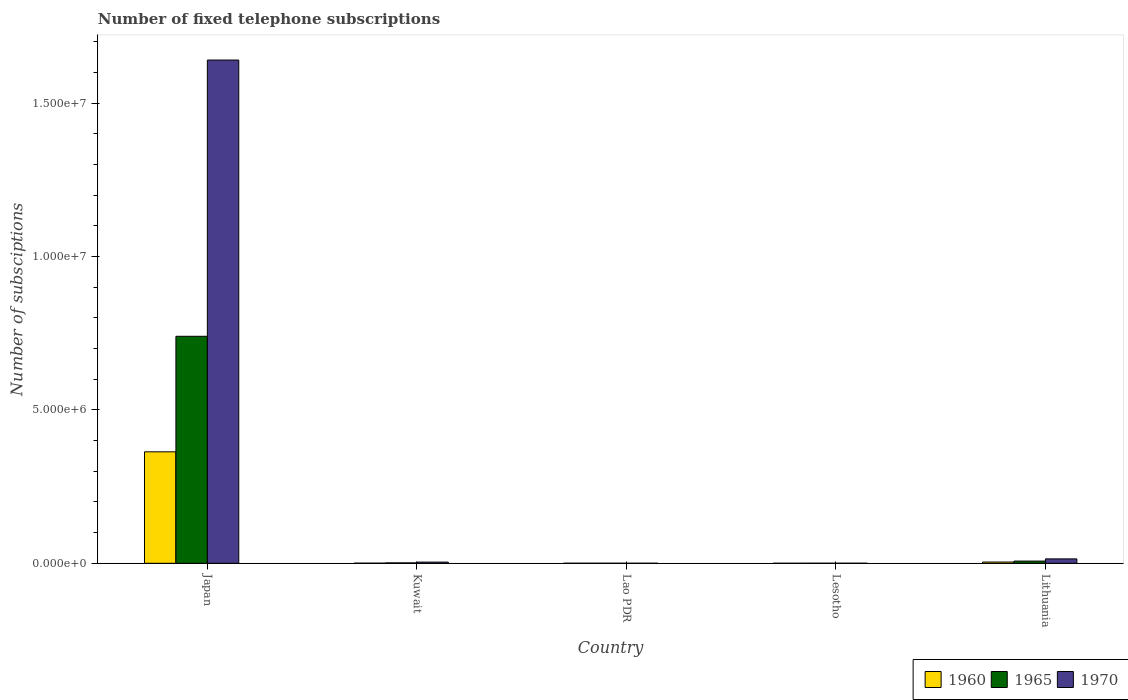How many different coloured bars are there?
Provide a succinct answer. 3. How many groups of bars are there?
Your response must be concise. 5. Are the number of bars per tick equal to the number of legend labels?
Offer a terse response. Yes. Are the number of bars on each tick of the X-axis equal?
Provide a succinct answer. Yes. How many bars are there on the 5th tick from the left?
Ensure brevity in your answer.  3. What is the label of the 2nd group of bars from the left?
Provide a succinct answer. Kuwait. In how many cases, is the number of bars for a given country not equal to the number of legend labels?
Offer a terse response. 0. What is the number of fixed telephone subscriptions in 1960 in Lithuania?
Offer a terse response. 4.04e+04. Across all countries, what is the maximum number of fixed telephone subscriptions in 1965?
Give a very brief answer. 7.40e+06. Across all countries, what is the minimum number of fixed telephone subscriptions in 1970?
Ensure brevity in your answer.  1100. In which country was the number of fixed telephone subscriptions in 1965 maximum?
Provide a short and direct response. Japan. In which country was the number of fixed telephone subscriptions in 1965 minimum?
Your answer should be compact. Lao PDR. What is the total number of fixed telephone subscriptions in 1960 in the graph?
Your answer should be compact. 3.68e+06. What is the difference between the number of fixed telephone subscriptions in 1960 in Lao PDR and that in Lesotho?
Offer a very short reply. 336. What is the difference between the number of fixed telephone subscriptions in 1970 in Lesotho and the number of fixed telephone subscriptions in 1960 in Kuwait?
Keep it short and to the point. -2016. What is the average number of fixed telephone subscriptions in 1960 per country?
Provide a succinct answer. 7.36e+05. What is the difference between the number of fixed telephone subscriptions of/in 1965 and number of fixed telephone subscriptions of/in 1970 in Kuwait?
Keep it short and to the point. -2.50e+04. In how many countries, is the number of fixed telephone subscriptions in 1965 greater than 1000000?
Provide a succinct answer. 1. What is the ratio of the number of fixed telephone subscriptions in 1965 in Kuwait to that in Lesotho?
Your answer should be compact. 10.83. Is the number of fixed telephone subscriptions in 1970 in Lesotho less than that in Lithuania?
Your answer should be compact. Yes. Is the difference between the number of fixed telephone subscriptions in 1965 in Lesotho and Lithuania greater than the difference between the number of fixed telephone subscriptions in 1970 in Lesotho and Lithuania?
Your response must be concise. Yes. What is the difference between the highest and the second highest number of fixed telephone subscriptions in 1970?
Keep it short and to the point. 1.63e+07. What is the difference between the highest and the lowest number of fixed telephone subscriptions in 1970?
Your response must be concise. 1.64e+07. Is the sum of the number of fixed telephone subscriptions in 1960 in Japan and Kuwait greater than the maximum number of fixed telephone subscriptions in 1970 across all countries?
Your answer should be very brief. No. What does the 3rd bar from the left in Kuwait represents?
Your answer should be compact. 1970. What does the 3rd bar from the right in Lao PDR represents?
Ensure brevity in your answer.  1960. How many countries are there in the graph?
Ensure brevity in your answer.  5. What is the title of the graph?
Give a very brief answer. Number of fixed telephone subscriptions. Does "1992" appear as one of the legend labels in the graph?
Your response must be concise. No. What is the label or title of the Y-axis?
Your answer should be very brief. Number of subsciptions. What is the Number of subsciptions in 1960 in Japan?
Your answer should be very brief. 3.63e+06. What is the Number of subsciptions in 1965 in Japan?
Make the answer very short. 7.40e+06. What is the Number of subsciptions of 1970 in Japan?
Provide a succinct answer. 1.64e+07. What is the Number of subsciptions of 1960 in Kuwait?
Your answer should be compact. 3316. What is the Number of subsciptions of 1965 in Kuwait?
Provide a succinct answer. 1.30e+04. What is the Number of subsciptions of 1970 in Kuwait?
Provide a short and direct response. 3.80e+04. What is the Number of subsciptions of 1960 in Lao PDR?
Offer a very short reply. 736. What is the Number of subsciptions in 1965 in Lao PDR?
Provide a short and direct response. 1000. What is the Number of subsciptions of 1970 in Lao PDR?
Keep it short and to the point. 1100. What is the Number of subsciptions of 1960 in Lesotho?
Provide a short and direct response. 400. What is the Number of subsciptions of 1965 in Lesotho?
Ensure brevity in your answer.  1200. What is the Number of subsciptions of 1970 in Lesotho?
Your answer should be very brief. 1300. What is the Number of subsciptions in 1960 in Lithuania?
Offer a terse response. 4.04e+04. What is the Number of subsciptions of 1965 in Lithuania?
Give a very brief answer. 7.18e+04. What is the Number of subsciptions in 1970 in Lithuania?
Keep it short and to the point. 1.43e+05. Across all countries, what is the maximum Number of subsciptions in 1960?
Provide a short and direct response. 3.63e+06. Across all countries, what is the maximum Number of subsciptions of 1965?
Offer a very short reply. 7.40e+06. Across all countries, what is the maximum Number of subsciptions in 1970?
Your answer should be very brief. 1.64e+07. Across all countries, what is the minimum Number of subsciptions of 1960?
Your response must be concise. 400. Across all countries, what is the minimum Number of subsciptions of 1965?
Provide a succinct answer. 1000. Across all countries, what is the minimum Number of subsciptions in 1970?
Your answer should be very brief. 1100. What is the total Number of subsciptions in 1960 in the graph?
Ensure brevity in your answer.  3.68e+06. What is the total Number of subsciptions in 1965 in the graph?
Your answer should be very brief. 7.49e+06. What is the total Number of subsciptions of 1970 in the graph?
Your response must be concise. 1.66e+07. What is the difference between the Number of subsciptions of 1960 in Japan and that in Kuwait?
Offer a very short reply. 3.63e+06. What is the difference between the Number of subsciptions of 1965 in Japan and that in Kuwait?
Give a very brief answer. 7.39e+06. What is the difference between the Number of subsciptions of 1970 in Japan and that in Kuwait?
Offer a terse response. 1.64e+07. What is the difference between the Number of subsciptions of 1960 in Japan and that in Lao PDR?
Offer a very short reply. 3.63e+06. What is the difference between the Number of subsciptions in 1965 in Japan and that in Lao PDR?
Make the answer very short. 7.40e+06. What is the difference between the Number of subsciptions of 1970 in Japan and that in Lao PDR?
Give a very brief answer. 1.64e+07. What is the difference between the Number of subsciptions in 1960 in Japan and that in Lesotho?
Ensure brevity in your answer.  3.63e+06. What is the difference between the Number of subsciptions of 1965 in Japan and that in Lesotho?
Provide a succinct answer. 7.40e+06. What is the difference between the Number of subsciptions of 1970 in Japan and that in Lesotho?
Your response must be concise. 1.64e+07. What is the difference between the Number of subsciptions in 1960 in Japan and that in Lithuania?
Ensure brevity in your answer.  3.59e+06. What is the difference between the Number of subsciptions of 1965 in Japan and that in Lithuania?
Your answer should be compact. 7.33e+06. What is the difference between the Number of subsciptions of 1970 in Japan and that in Lithuania?
Ensure brevity in your answer.  1.63e+07. What is the difference between the Number of subsciptions in 1960 in Kuwait and that in Lao PDR?
Provide a short and direct response. 2580. What is the difference between the Number of subsciptions in 1965 in Kuwait and that in Lao PDR?
Make the answer very short. 1.20e+04. What is the difference between the Number of subsciptions in 1970 in Kuwait and that in Lao PDR?
Offer a terse response. 3.69e+04. What is the difference between the Number of subsciptions of 1960 in Kuwait and that in Lesotho?
Ensure brevity in your answer.  2916. What is the difference between the Number of subsciptions of 1965 in Kuwait and that in Lesotho?
Give a very brief answer. 1.18e+04. What is the difference between the Number of subsciptions of 1970 in Kuwait and that in Lesotho?
Offer a very short reply. 3.67e+04. What is the difference between the Number of subsciptions in 1960 in Kuwait and that in Lithuania?
Ensure brevity in your answer.  -3.71e+04. What is the difference between the Number of subsciptions of 1965 in Kuwait and that in Lithuania?
Make the answer very short. -5.88e+04. What is the difference between the Number of subsciptions of 1970 in Kuwait and that in Lithuania?
Make the answer very short. -1.05e+05. What is the difference between the Number of subsciptions of 1960 in Lao PDR and that in Lesotho?
Provide a short and direct response. 336. What is the difference between the Number of subsciptions in 1965 in Lao PDR and that in Lesotho?
Provide a succinct answer. -200. What is the difference between the Number of subsciptions in 1970 in Lao PDR and that in Lesotho?
Keep it short and to the point. -200. What is the difference between the Number of subsciptions in 1960 in Lao PDR and that in Lithuania?
Offer a terse response. -3.97e+04. What is the difference between the Number of subsciptions in 1965 in Lao PDR and that in Lithuania?
Your answer should be compact. -7.08e+04. What is the difference between the Number of subsciptions in 1970 in Lao PDR and that in Lithuania?
Offer a very short reply. -1.42e+05. What is the difference between the Number of subsciptions of 1960 in Lesotho and that in Lithuania?
Ensure brevity in your answer.  -4.00e+04. What is the difference between the Number of subsciptions of 1965 in Lesotho and that in Lithuania?
Your answer should be very brief. -7.06e+04. What is the difference between the Number of subsciptions of 1970 in Lesotho and that in Lithuania?
Give a very brief answer. -1.42e+05. What is the difference between the Number of subsciptions of 1960 in Japan and the Number of subsciptions of 1965 in Kuwait?
Your answer should be very brief. 3.62e+06. What is the difference between the Number of subsciptions of 1960 in Japan and the Number of subsciptions of 1970 in Kuwait?
Provide a short and direct response. 3.59e+06. What is the difference between the Number of subsciptions of 1965 in Japan and the Number of subsciptions of 1970 in Kuwait?
Keep it short and to the point. 7.36e+06. What is the difference between the Number of subsciptions in 1960 in Japan and the Number of subsciptions in 1965 in Lao PDR?
Your answer should be very brief. 3.63e+06. What is the difference between the Number of subsciptions of 1960 in Japan and the Number of subsciptions of 1970 in Lao PDR?
Give a very brief answer. 3.63e+06. What is the difference between the Number of subsciptions of 1965 in Japan and the Number of subsciptions of 1970 in Lao PDR?
Give a very brief answer. 7.40e+06. What is the difference between the Number of subsciptions of 1960 in Japan and the Number of subsciptions of 1965 in Lesotho?
Ensure brevity in your answer.  3.63e+06. What is the difference between the Number of subsciptions of 1960 in Japan and the Number of subsciptions of 1970 in Lesotho?
Give a very brief answer. 3.63e+06. What is the difference between the Number of subsciptions in 1965 in Japan and the Number of subsciptions in 1970 in Lesotho?
Offer a terse response. 7.40e+06. What is the difference between the Number of subsciptions of 1960 in Japan and the Number of subsciptions of 1965 in Lithuania?
Ensure brevity in your answer.  3.56e+06. What is the difference between the Number of subsciptions in 1960 in Japan and the Number of subsciptions in 1970 in Lithuania?
Your response must be concise. 3.49e+06. What is the difference between the Number of subsciptions in 1965 in Japan and the Number of subsciptions in 1970 in Lithuania?
Your response must be concise. 7.26e+06. What is the difference between the Number of subsciptions in 1960 in Kuwait and the Number of subsciptions in 1965 in Lao PDR?
Give a very brief answer. 2316. What is the difference between the Number of subsciptions of 1960 in Kuwait and the Number of subsciptions of 1970 in Lao PDR?
Keep it short and to the point. 2216. What is the difference between the Number of subsciptions in 1965 in Kuwait and the Number of subsciptions in 1970 in Lao PDR?
Keep it short and to the point. 1.19e+04. What is the difference between the Number of subsciptions of 1960 in Kuwait and the Number of subsciptions of 1965 in Lesotho?
Keep it short and to the point. 2116. What is the difference between the Number of subsciptions of 1960 in Kuwait and the Number of subsciptions of 1970 in Lesotho?
Your answer should be compact. 2016. What is the difference between the Number of subsciptions in 1965 in Kuwait and the Number of subsciptions in 1970 in Lesotho?
Your response must be concise. 1.17e+04. What is the difference between the Number of subsciptions of 1960 in Kuwait and the Number of subsciptions of 1965 in Lithuania?
Give a very brief answer. -6.85e+04. What is the difference between the Number of subsciptions of 1960 in Kuwait and the Number of subsciptions of 1970 in Lithuania?
Offer a terse response. -1.40e+05. What is the difference between the Number of subsciptions of 1965 in Kuwait and the Number of subsciptions of 1970 in Lithuania?
Your response must be concise. -1.30e+05. What is the difference between the Number of subsciptions in 1960 in Lao PDR and the Number of subsciptions in 1965 in Lesotho?
Your response must be concise. -464. What is the difference between the Number of subsciptions in 1960 in Lao PDR and the Number of subsciptions in 1970 in Lesotho?
Keep it short and to the point. -564. What is the difference between the Number of subsciptions of 1965 in Lao PDR and the Number of subsciptions of 1970 in Lesotho?
Give a very brief answer. -300. What is the difference between the Number of subsciptions of 1960 in Lao PDR and the Number of subsciptions of 1965 in Lithuania?
Your response must be concise. -7.11e+04. What is the difference between the Number of subsciptions of 1960 in Lao PDR and the Number of subsciptions of 1970 in Lithuania?
Your answer should be very brief. -1.42e+05. What is the difference between the Number of subsciptions of 1965 in Lao PDR and the Number of subsciptions of 1970 in Lithuania?
Provide a succinct answer. -1.42e+05. What is the difference between the Number of subsciptions in 1960 in Lesotho and the Number of subsciptions in 1965 in Lithuania?
Your answer should be very brief. -7.14e+04. What is the difference between the Number of subsciptions of 1960 in Lesotho and the Number of subsciptions of 1970 in Lithuania?
Your answer should be very brief. -1.43e+05. What is the difference between the Number of subsciptions in 1965 in Lesotho and the Number of subsciptions in 1970 in Lithuania?
Keep it short and to the point. -1.42e+05. What is the average Number of subsciptions in 1960 per country?
Your answer should be very brief. 7.36e+05. What is the average Number of subsciptions in 1965 per country?
Offer a terse response. 1.50e+06. What is the average Number of subsciptions in 1970 per country?
Your answer should be very brief. 3.32e+06. What is the difference between the Number of subsciptions in 1960 and Number of subsciptions in 1965 in Japan?
Your answer should be very brief. -3.77e+06. What is the difference between the Number of subsciptions in 1960 and Number of subsciptions in 1970 in Japan?
Provide a short and direct response. -1.28e+07. What is the difference between the Number of subsciptions in 1965 and Number of subsciptions in 1970 in Japan?
Your answer should be compact. -9.00e+06. What is the difference between the Number of subsciptions in 1960 and Number of subsciptions in 1965 in Kuwait?
Make the answer very short. -9684. What is the difference between the Number of subsciptions in 1960 and Number of subsciptions in 1970 in Kuwait?
Your response must be concise. -3.47e+04. What is the difference between the Number of subsciptions in 1965 and Number of subsciptions in 1970 in Kuwait?
Offer a terse response. -2.50e+04. What is the difference between the Number of subsciptions of 1960 and Number of subsciptions of 1965 in Lao PDR?
Your answer should be very brief. -264. What is the difference between the Number of subsciptions in 1960 and Number of subsciptions in 1970 in Lao PDR?
Provide a succinct answer. -364. What is the difference between the Number of subsciptions in 1965 and Number of subsciptions in 1970 in Lao PDR?
Provide a succinct answer. -100. What is the difference between the Number of subsciptions of 1960 and Number of subsciptions of 1965 in Lesotho?
Provide a succinct answer. -800. What is the difference between the Number of subsciptions in 1960 and Number of subsciptions in 1970 in Lesotho?
Provide a short and direct response. -900. What is the difference between the Number of subsciptions of 1965 and Number of subsciptions of 1970 in Lesotho?
Ensure brevity in your answer.  -100. What is the difference between the Number of subsciptions of 1960 and Number of subsciptions of 1965 in Lithuania?
Your answer should be compact. -3.15e+04. What is the difference between the Number of subsciptions of 1960 and Number of subsciptions of 1970 in Lithuania?
Offer a terse response. -1.03e+05. What is the difference between the Number of subsciptions in 1965 and Number of subsciptions in 1970 in Lithuania?
Ensure brevity in your answer.  -7.14e+04. What is the ratio of the Number of subsciptions of 1960 in Japan to that in Kuwait?
Make the answer very short. 1095.58. What is the ratio of the Number of subsciptions in 1965 in Japan to that in Kuwait?
Provide a short and direct response. 569.15. What is the ratio of the Number of subsciptions of 1970 in Japan to that in Kuwait?
Ensure brevity in your answer.  431.66. What is the ratio of the Number of subsciptions in 1960 in Japan to that in Lao PDR?
Offer a terse response. 4936.06. What is the ratio of the Number of subsciptions of 1965 in Japan to that in Lao PDR?
Give a very brief answer. 7399. What is the ratio of the Number of subsciptions in 1970 in Japan to that in Lao PDR?
Your response must be concise. 1.49e+04. What is the ratio of the Number of subsciptions of 1960 in Japan to that in Lesotho?
Your answer should be very brief. 9082.34. What is the ratio of the Number of subsciptions in 1965 in Japan to that in Lesotho?
Offer a terse response. 6165.83. What is the ratio of the Number of subsciptions in 1970 in Japan to that in Lesotho?
Give a very brief answer. 1.26e+04. What is the ratio of the Number of subsciptions of 1960 in Japan to that in Lithuania?
Provide a short and direct response. 89.95. What is the ratio of the Number of subsciptions of 1965 in Japan to that in Lithuania?
Give a very brief answer. 102.99. What is the ratio of the Number of subsciptions of 1970 in Japan to that in Lithuania?
Keep it short and to the point. 114.53. What is the ratio of the Number of subsciptions in 1960 in Kuwait to that in Lao PDR?
Ensure brevity in your answer.  4.51. What is the ratio of the Number of subsciptions of 1965 in Kuwait to that in Lao PDR?
Provide a short and direct response. 13. What is the ratio of the Number of subsciptions in 1970 in Kuwait to that in Lao PDR?
Give a very brief answer. 34.55. What is the ratio of the Number of subsciptions of 1960 in Kuwait to that in Lesotho?
Make the answer very short. 8.29. What is the ratio of the Number of subsciptions of 1965 in Kuwait to that in Lesotho?
Make the answer very short. 10.83. What is the ratio of the Number of subsciptions in 1970 in Kuwait to that in Lesotho?
Keep it short and to the point. 29.23. What is the ratio of the Number of subsciptions in 1960 in Kuwait to that in Lithuania?
Provide a short and direct response. 0.08. What is the ratio of the Number of subsciptions of 1965 in Kuwait to that in Lithuania?
Provide a short and direct response. 0.18. What is the ratio of the Number of subsciptions in 1970 in Kuwait to that in Lithuania?
Ensure brevity in your answer.  0.27. What is the ratio of the Number of subsciptions in 1960 in Lao PDR to that in Lesotho?
Your response must be concise. 1.84. What is the ratio of the Number of subsciptions of 1965 in Lao PDR to that in Lesotho?
Your answer should be compact. 0.83. What is the ratio of the Number of subsciptions in 1970 in Lao PDR to that in Lesotho?
Provide a short and direct response. 0.85. What is the ratio of the Number of subsciptions of 1960 in Lao PDR to that in Lithuania?
Give a very brief answer. 0.02. What is the ratio of the Number of subsciptions in 1965 in Lao PDR to that in Lithuania?
Your answer should be compact. 0.01. What is the ratio of the Number of subsciptions of 1970 in Lao PDR to that in Lithuania?
Your answer should be compact. 0.01. What is the ratio of the Number of subsciptions in 1960 in Lesotho to that in Lithuania?
Offer a terse response. 0.01. What is the ratio of the Number of subsciptions of 1965 in Lesotho to that in Lithuania?
Your answer should be very brief. 0.02. What is the ratio of the Number of subsciptions of 1970 in Lesotho to that in Lithuania?
Give a very brief answer. 0.01. What is the difference between the highest and the second highest Number of subsciptions of 1960?
Your answer should be compact. 3.59e+06. What is the difference between the highest and the second highest Number of subsciptions in 1965?
Ensure brevity in your answer.  7.33e+06. What is the difference between the highest and the second highest Number of subsciptions of 1970?
Make the answer very short. 1.63e+07. What is the difference between the highest and the lowest Number of subsciptions of 1960?
Your answer should be compact. 3.63e+06. What is the difference between the highest and the lowest Number of subsciptions in 1965?
Provide a succinct answer. 7.40e+06. What is the difference between the highest and the lowest Number of subsciptions of 1970?
Your answer should be compact. 1.64e+07. 